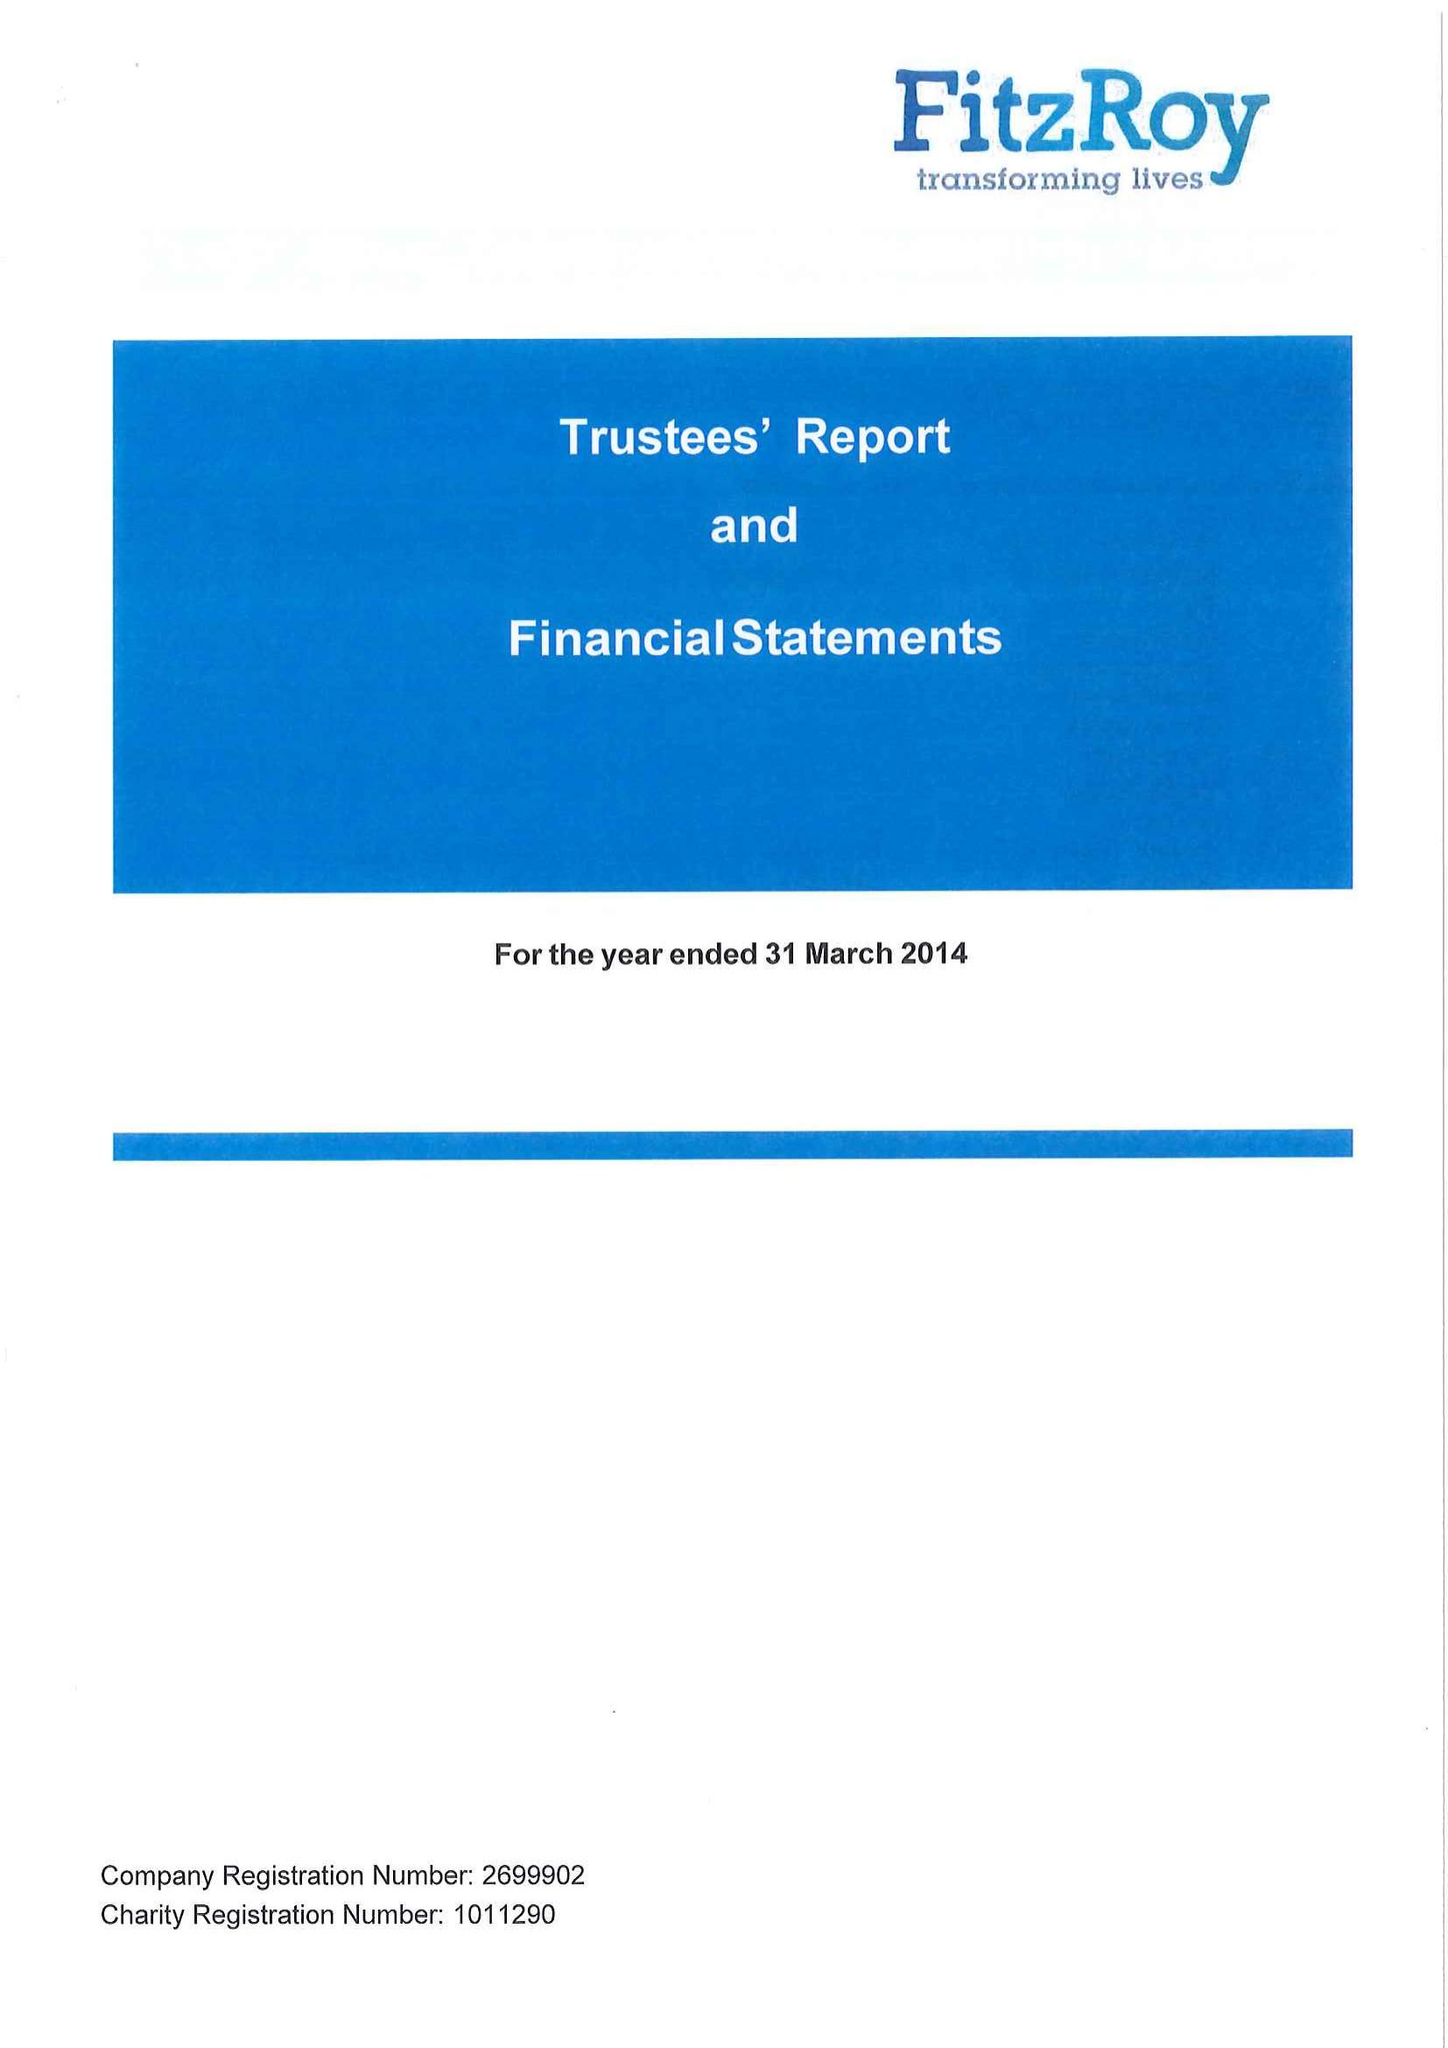What is the value for the charity_name?
Answer the question using a single word or phrase. Fitzroy Support 